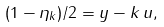Convert formula to latex. <formula><loc_0><loc_0><loc_500><loc_500>( 1 - \eta _ { k } ) / 2 = y - k \, u ,</formula> 